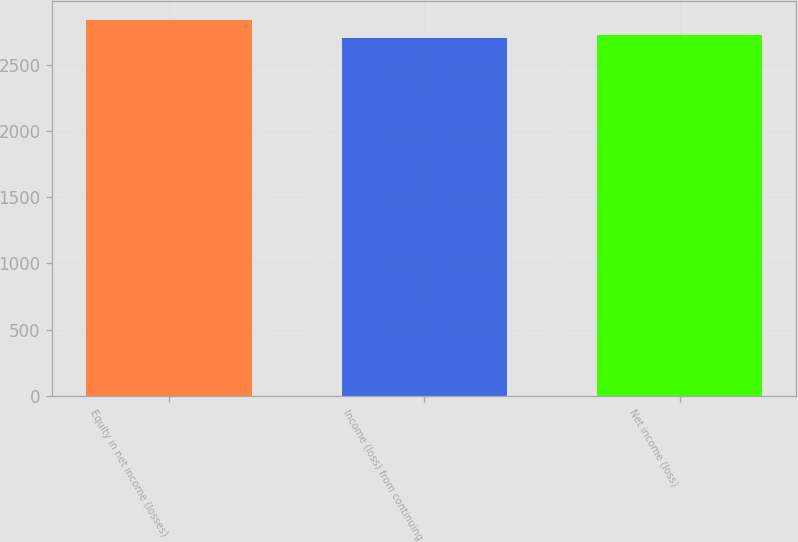Convert chart. <chart><loc_0><loc_0><loc_500><loc_500><bar_chart><fcel>Equity in net income (losses)<fcel>Income (loss) from continuing<fcel>Net income (loss)<nl><fcel>2842<fcel>2704<fcel>2725.2<nl></chart> 